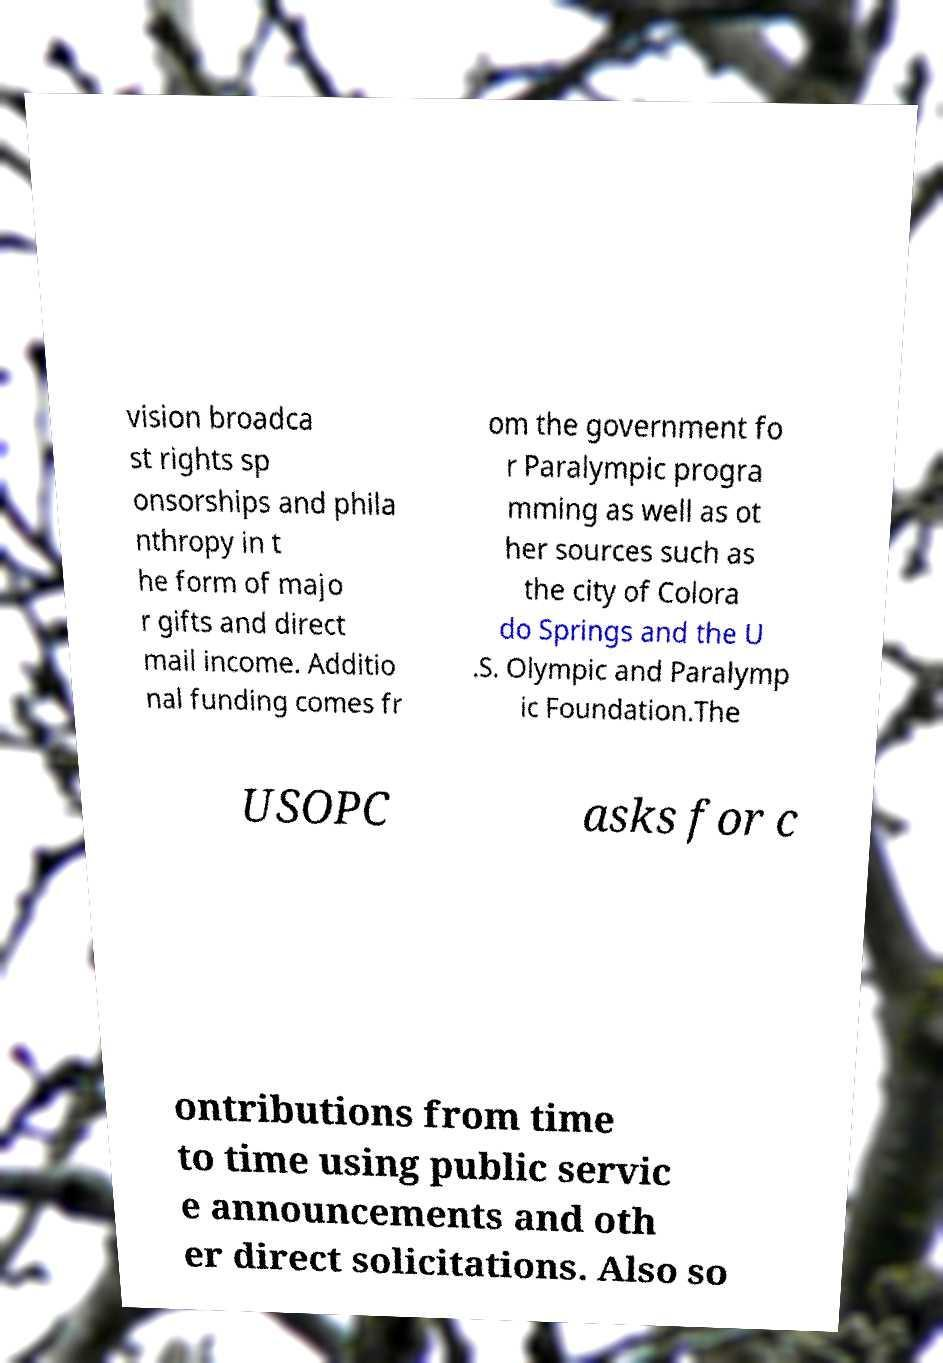I need the written content from this picture converted into text. Can you do that? vision broadca st rights sp onsorships and phila nthropy in t he form of majo r gifts and direct mail income. Additio nal funding comes fr om the government fo r Paralympic progra mming as well as ot her sources such as the city of Colora do Springs and the U .S. Olympic and Paralymp ic Foundation.The USOPC asks for c ontributions from time to time using public servic e announcements and oth er direct solicitations. Also so 